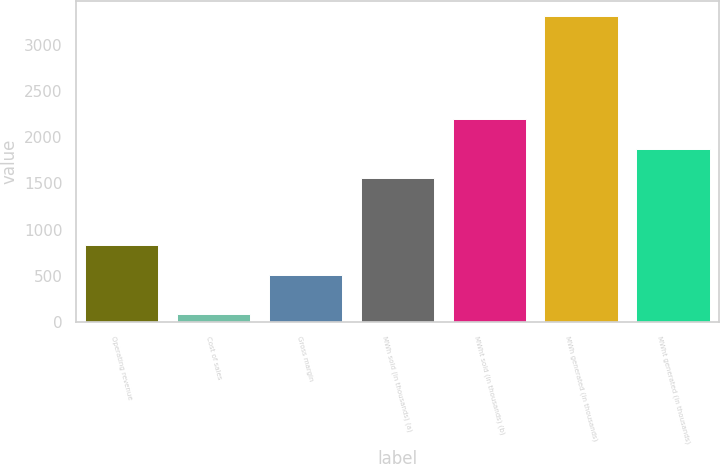<chart> <loc_0><loc_0><loc_500><loc_500><bar_chart><fcel>Operating revenue<fcel>Cost of sales<fcel>Gross margin<fcel>MWh sold (in thousands) (a)<fcel>MWht sold (in thousands) (b)<fcel>MWh generated (in thousands)<fcel>MWht generated (in thousands)<nl><fcel>834.8<fcel>88<fcel>513<fcel>1552<fcel>2195.6<fcel>3306<fcel>1873.8<nl></chart> 